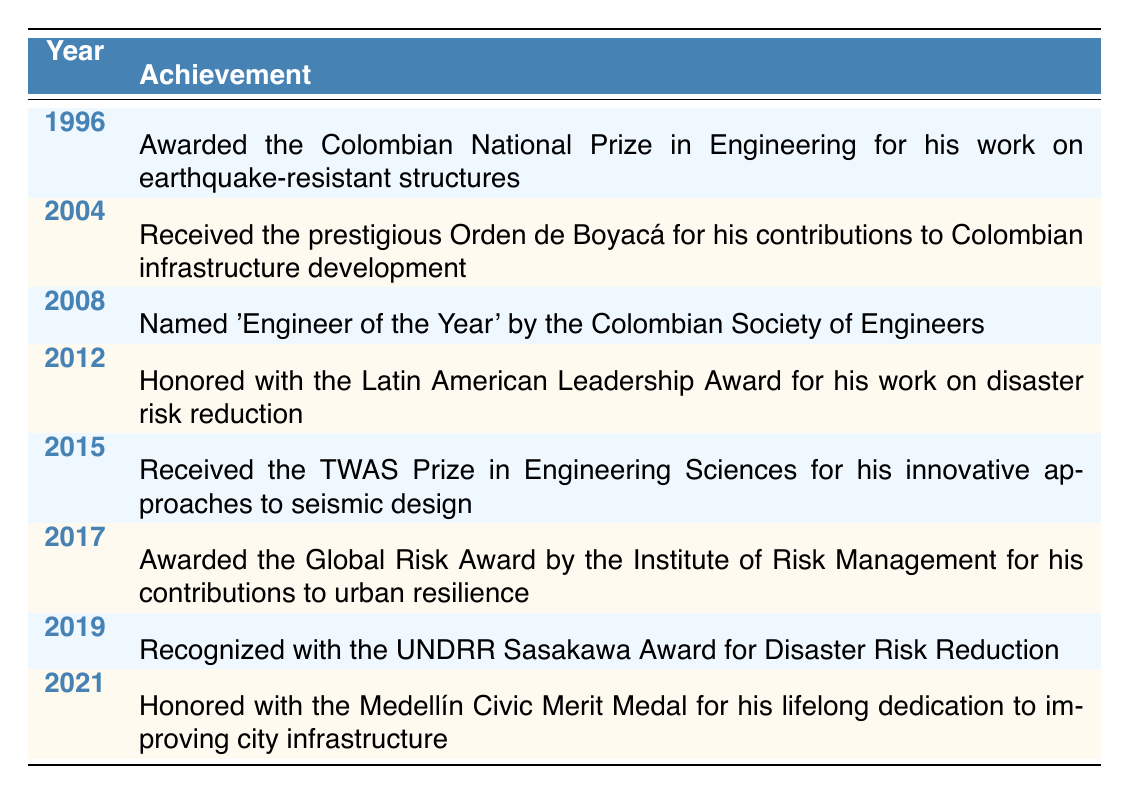What award did Cardona receive in 1996? In 1996, Cardona was awarded the Colombian National Prize in Engineering.
Answer: Colombian National Prize in Engineering How many total awards are listed for Cardona? There are 8 achievements and awards listed in the table.
Answer: 8 Did Cardona receive the Orden de Boyacá before 2010? Yes, the Orden de Boyacá was received in 2004, which is before 2010.
Answer: Yes What is the achievement Cardona received in 2015? In 2015, Cardona received the TWAS Prize in Engineering Sciences.
Answer: TWAS Prize in Engineering Sciences Between which years did Cardona receive the most awards? The years that have the most awards are 1996 to 2021, covering a span of 25 years with 8 awards.
Answer: 1996 to 2021 Which award did Cardona receive that specifically relates to disaster risk reduction? Cardona was honored with the UNDRR Sasakawa Award for Disaster Risk Reduction in 2019.
Answer: UNDRR Sasakawa Award What pattern can be observed in the years of awards received by Cardona? The awards appear consistently over time, with notable achievements every few years from 1996 to 2021.
Answer: Consistent pattern What is the time span between the first and the last award Cardona received? The first award was in 1996, and the last was in 2021, making the time span 25 years.
Answer: 25 years In which year did Cardona receive recognition as 'Engineer of the Year'? Cardona was named 'Engineer of the Year' in 2008.
Answer: 2008 Did Cardona receive any awards in the 2000s decade? Yes, Cardona received awards in 2004 and 2008 during the 2000s decade.
Answer: Yes 